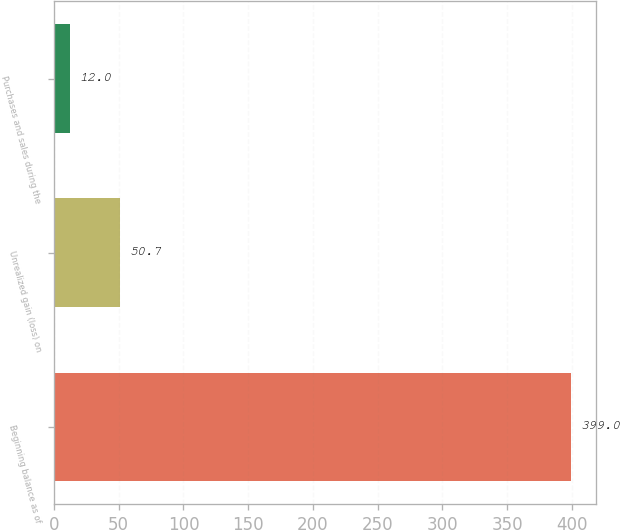Convert chart. <chart><loc_0><loc_0><loc_500><loc_500><bar_chart><fcel>Beginning balance as of<fcel>Unrealized gain (loss) on<fcel>Purchases and sales during the<nl><fcel>399<fcel>50.7<fcel>12<nl></chart> 